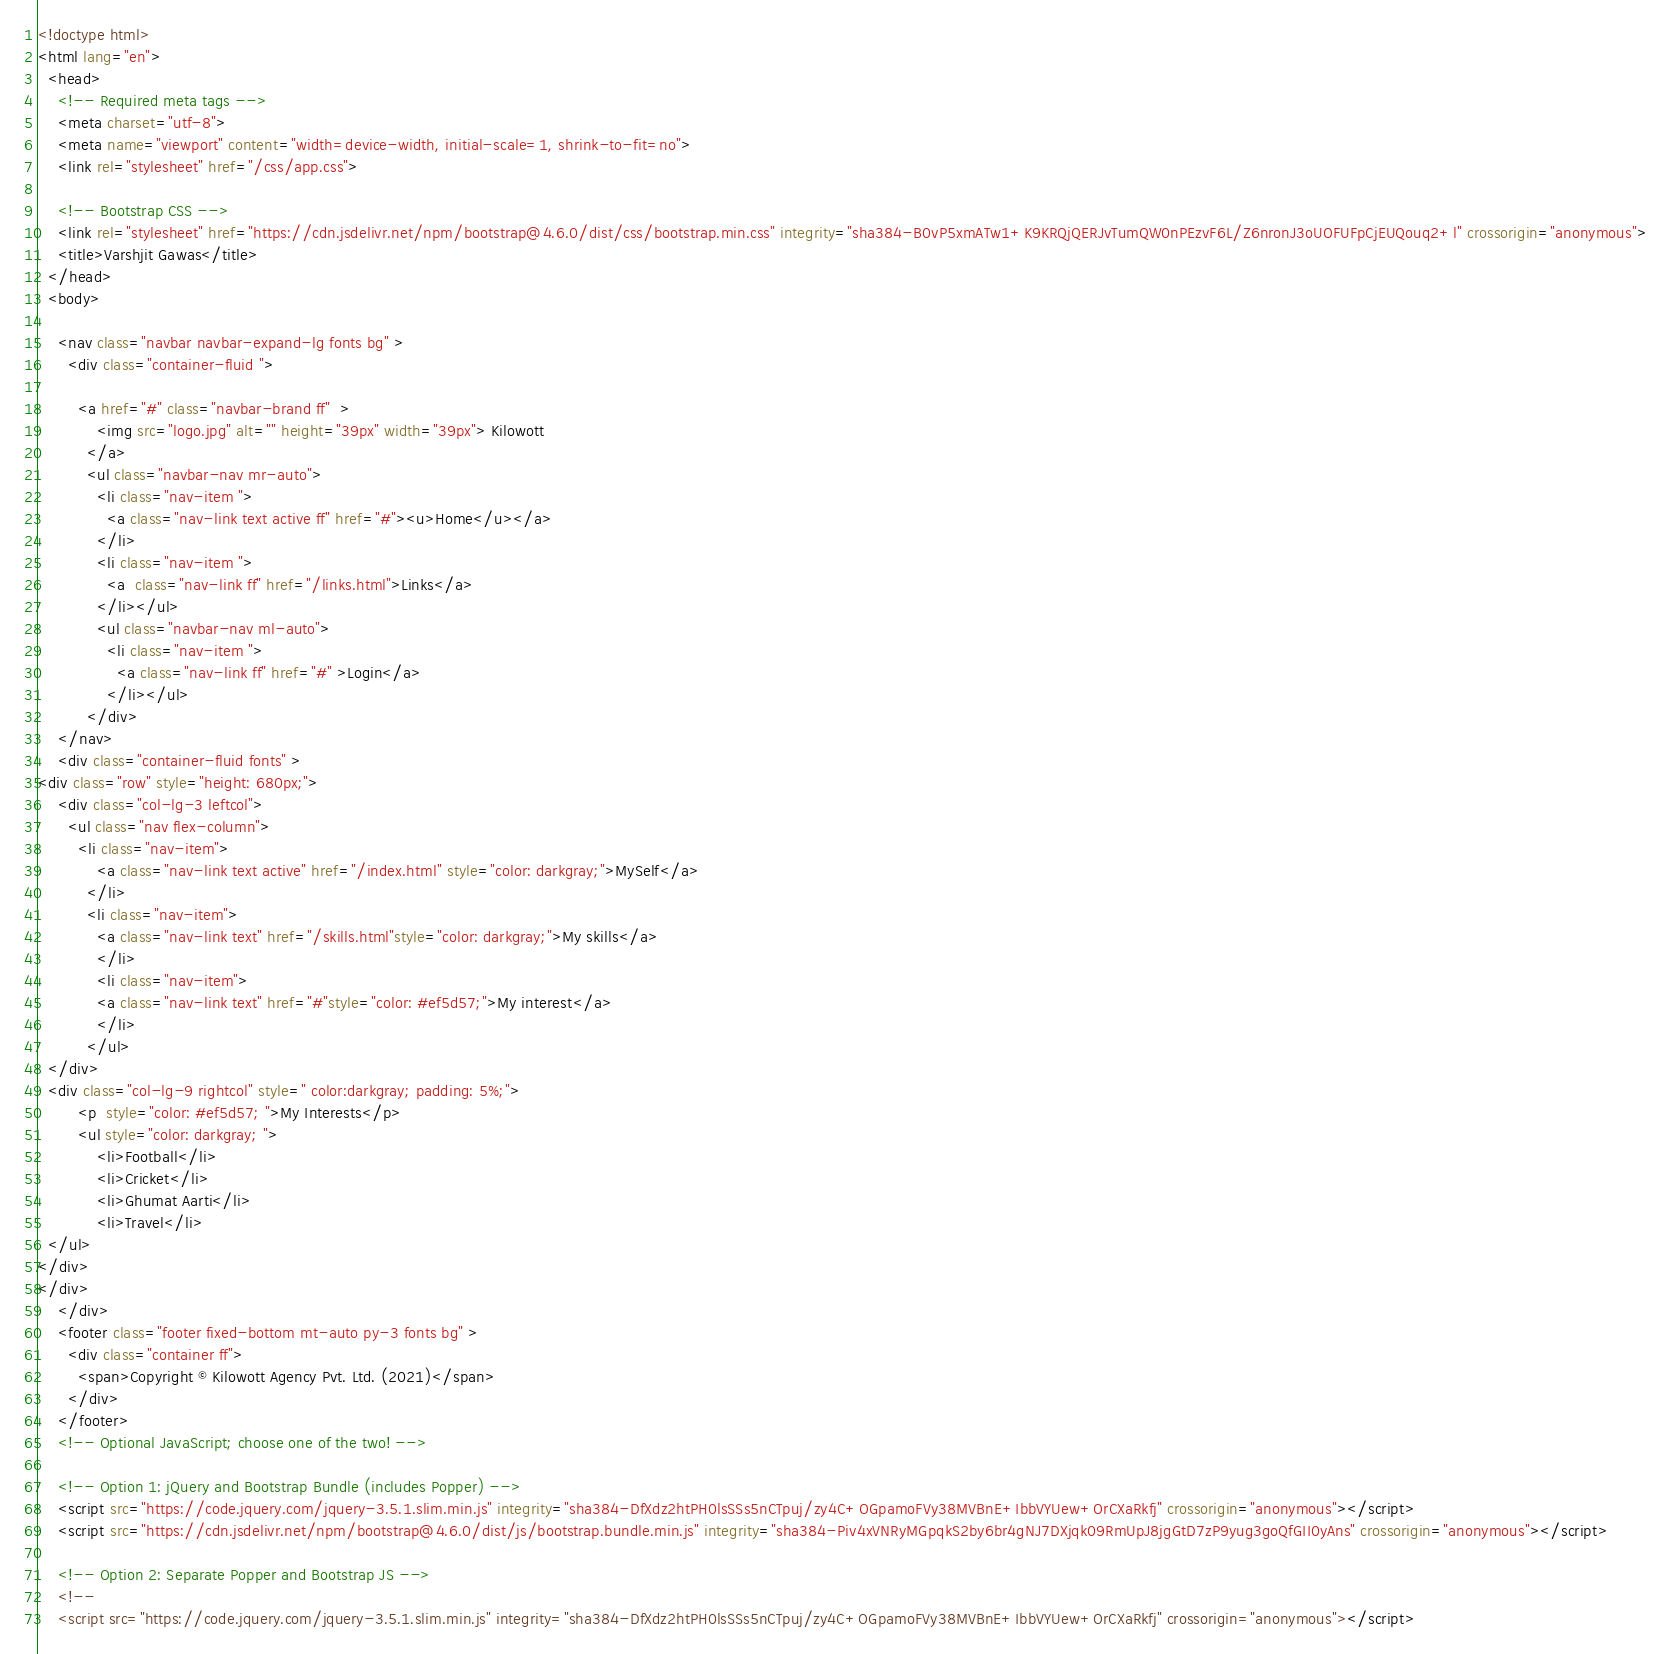Convert code to text. <code><loc_0><loc_0><loc_500><loc_500><_HTML_><!doctype html>
<html lang="en">
  <head>
    <!-- Required meta tags -->
    <meta charset="utf-8">
    <meta name="viewport" content="width=device-width, initial-scale=1, shrink-to-fit=no">
    <link rel="stylesheet" href="/css/app.css">

    <!-- Bootstrap CSS -->
    <link rel="stylesheet" href="https://cdn.jsdelivr.net/npm/bootstrap@4.6.0/dist/css/bootstrap.min.css" integrity="sha384-B0vP5xmATw1+K9KRQjQERJvTumQW0nPEzvF6L/Z6nronJ3oUOFUFpCjEUQouq2+l" crossorigin="anonymous">
    <title>Varshjit Gawas</title>
  </head>
  <body>
      
    <nav class="navbar navbar-expand-lg fonts bg" >
      <div class="container-fluid ">

        <a href="#" class="navbar-brand ff"  >
            <img src="logo.jpg" alt="" height="39px" width="39px"> Kilowott
          </a>
          <ul class="navbar-nav mr-auto">
            <li class="nav-item ">
              <a class="nav-link text active ff" href="#"><u>Home</u></a>
            </li>
            <li class="nav-item ">
              <a  class="nav-link ff" href="/links.html">Links</a>
            </li></ul>
            <ul class="navbar-nav ml-auto">
              <li class="nav-item ">
                <a class="nav-link ff" href="#" >Login</a>
              </li></ul>
          </div>
    </nav>
    <div class="container-fluid fonts" >
<div class="row" style="height: 680px;">
    <div class="col-lg-3 leftcol">  
      <ul class="nav flex-column">
        <li class="nav-item">
            <a class="nav-link text active" href="/index.html" style="color: darkgray;">MySelf</a>
          </li>
          <li class="nav-item">
            <a class="nav-link text" href="/skills.html"style="color: darkgray;">My skills</a>
            </li>
            <li class="nav-item">
            <a class="nav-link text" href="#"style="color: #ef5d57;">My interest</a>
            </li>
          </ul>
  </div>
  <div class="col-lg-9 rightcol" style=" color:darkgray; padding: 5%;">
        <p  style="color: #ef5d57; ">My Interests</p>
        <ul style="color: darkgray; ">
            <li>Football</li>
            <li>Cricket</li>
            <li>Ghumat Aarti</li>
            <li>Travel</li>
  </ul>
</div>
</div>
    </div>
    <footer class="footer fixed-bottom mt-auto py-3 fonts bg" >
      <div class="container ff">
        <span>Copyright © Kilowott Agency Pvt. Ltd. (2021)</span>
      </div>
    </footer>
    <!-- Optional JavaScript; choose one of the two! -->

    <!-- Option 1: jQuery and Bootstrap Bundle (includes Popper) -->
    <script src="https://code.jquery.com/jquery-3.5.1.slim.min.js" integrity="sha384-DfXdz2htPH0lsSSs5nCTpuj/zy4C+OGpamoFVy38MVBnE+IbbVYUew+OrCXaRkfj" crossorigin="anonymous"></script>
    <script src="https://cdn.jsdelivr.net/npm/bootstrap@4.6.0/dist/js/bootstrap.bundle.min.js" integrity="sha384-Piv4xVNRyMGpqkS2by6br4gNJ7DXjqk09RmUpJ8jgGtD7zP9yug3goQfGII0yAns" crossorigin="anonymous"></script>

    <!-- Option 2: Separate Popper and Bootstrap JS -->
    <!--
    <script src="https://code.jquery.com/jquery-3.5.1.slim.min.js" integrity="sha384-DfXdz2htPH0lsSSs5nCTpuj/zy4C+OGpamoFVy38MVBnE+IbbVYUew+OrCXaRkfj" crossorigin="anonymous"></script></code> 